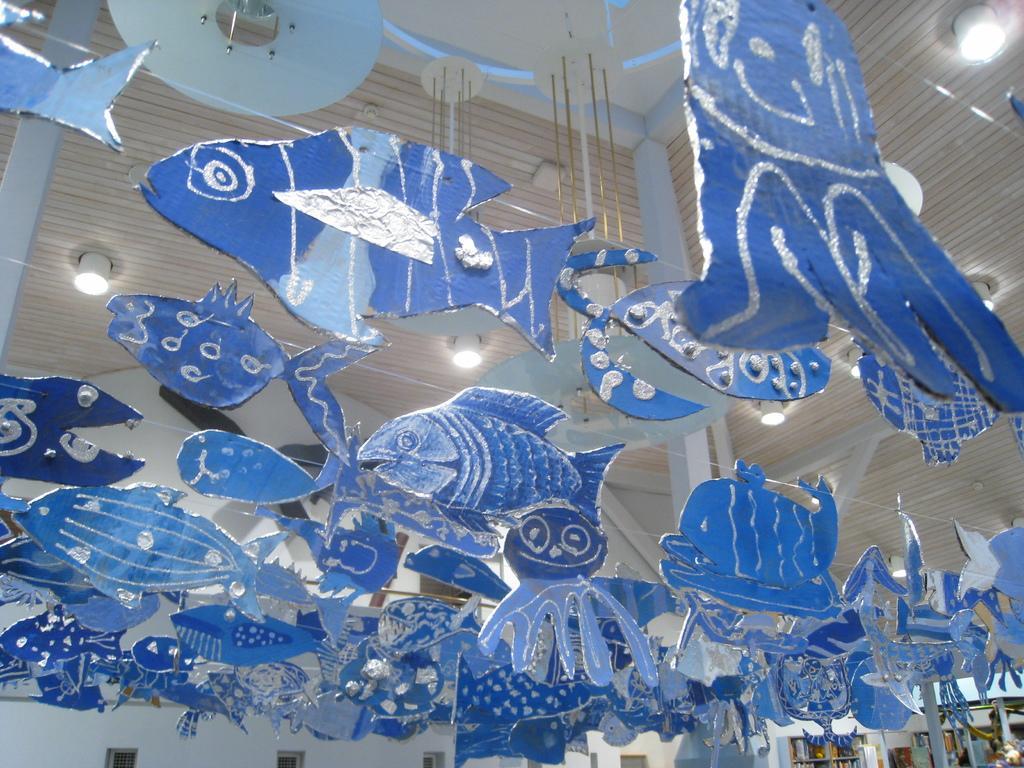Describe this image in one or two sentences. In this image, I can see cardboard fishes, octopus and chandeliers are hanged on a rooftop. In the background, I can see pillars and some objects. This image taken, maybe in a hall. 